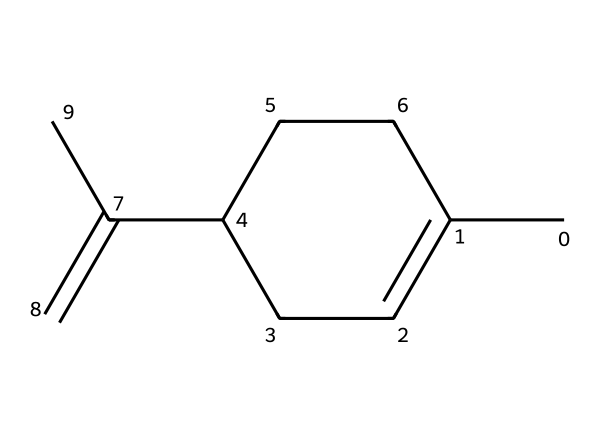What is the molecular formula of limonene? To determine the molecular formula, count the number of carbon (C) and hydrogen (H) atoms in the SMILES representation. There are 10 carbon atoms and 16 hydrogen atoms. Therefore, the molecular formula is C10H16.
Answer: C10H16 How many rings does limonene have in its structure? Analyzing the structure, we observe there is one cyclic part formed by the carbon atoms. Therefore, limonene has one ring.
Answer: one What type of compound is limonene classified as? Limonene's structure, which includes double bonds in a cyclic compound, indicates it is classified as a monoterpene.
Answer: monoterpene What is the degree of unsaturation in limonene? To find the degree of unsaturation, we can use the formula: (2C + 2 + N - H - X) / 2. Here, C=10, H=16, so the formula becomes (2*10 + 2 - 16) / 2 = 3. The degree of unsaturation is 3, indicating three double bonds or rings.
Answer: 3 Which part of the structure contributes to the citrus scent of limonene? The structural feature that mainly contributes to the citrus scent is the specific arrangement of double bonds and the cyclic ring. This unique arrangement is typical of natural terpenes found in citrus fruits.
Answer: cyclic ring Is limonene chiral? Evaluating the symmetry of the molecule, we find that there is one carbon center connected to four different substituents, indicating chirality. Thus, limonene is chiral.
Answer: chiral 